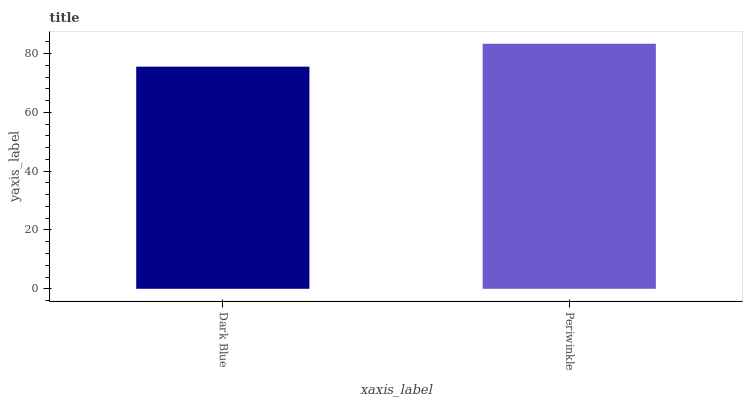Is Dark Blue the minimum?
Answer yes or no. Yes. Is Periwinkle the maximum?
Answer yes or no. Yes. Is Periwinkle the minimum?
Answer yes or no. No. Is Periwinkle greater than Dark Blue?
Answer yes or no. Yes. Is Dark Blue less than Periwinkle?
Answer yes or no. Yes. Is Dark Blue greater than Periwinkle?
Answer yes or no. No. Is Periwinkle less than Dark Blue?
Answer yes or no. No. Is Periwinkle the high median?
Answer yes or no. Yes. Is Dark Blue the low median?
Answer yes or no. Yes. Is Dark Blue the high median?
Answer yes or no. No. Is Periwinkle the low median?
Answer yes or no. No. 